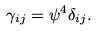<formula> <loc_0><loc_0><loc_500><loc_500>\gamma _ { i j } = { \psi } ^ { 4 } \delta _ { i j } .</formula> 